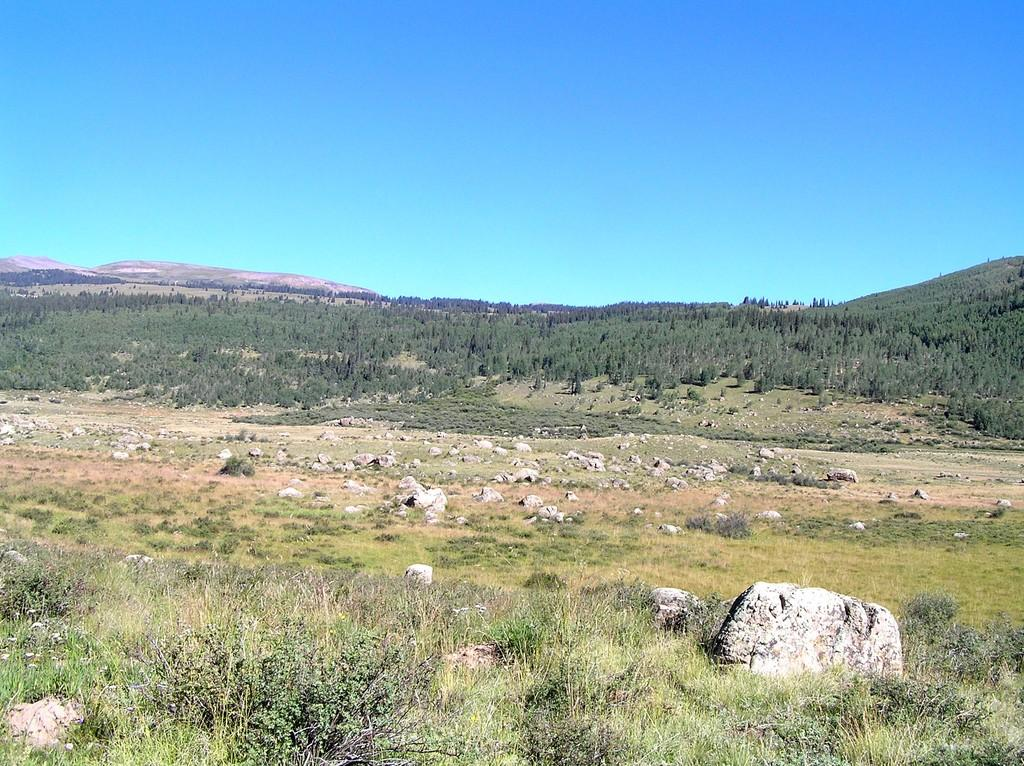What type of natural elements can be seen on the ground in the image? There are rocks and plants on the ground in the image. What type of vegetation is visible in the background of the image? There are trees in the background of the image. What part of the natural environment is visible in the background of the image? The sky is visible in the background of the image. What type of cake is being blown out in the image? There is no cake or blowing out of candles present in the image. How does the look of the plants change in the image? The image does not depict any changes in the appearance of the plants. 